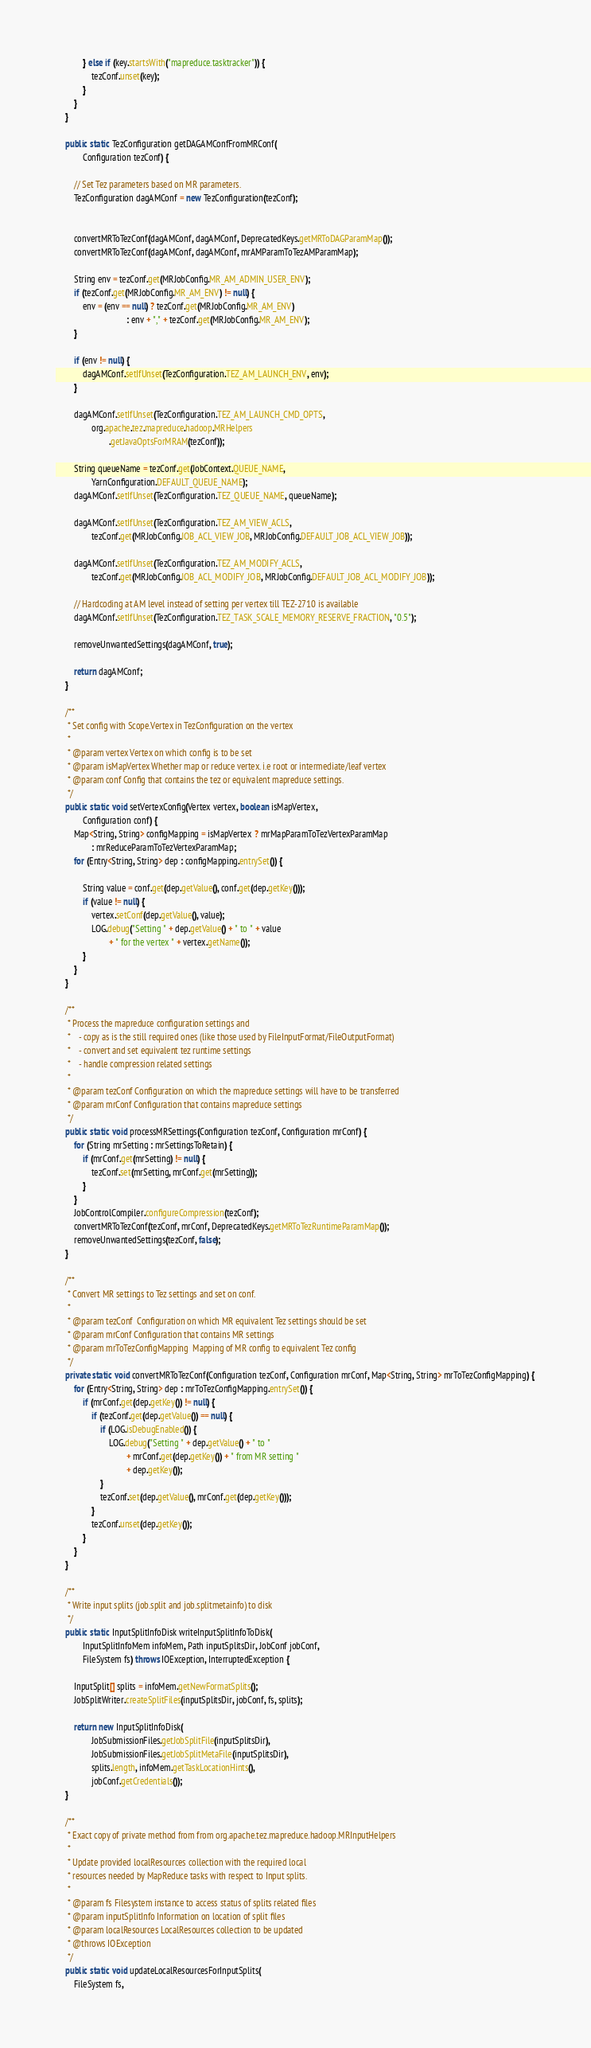<code> <loc_0><loc_0><loc_500><loc_500><_Java_>            } else if (key.startsWith("mapreduce.tasktracker")) {
                tezConf.unset(key);
            }
        }
    }

    public static TezConfiguration getDAGAMConfFromMRConf(
            Configuration tezConf) {

        // Set Tez parameters based on MR parameters.
        TezConfiguration dagAMConf = new TezConfiguration(tezConf);


        convertMRToTezConf(dagAMConf, dagAMConf, DeprecatedKeys.getMRToDAGParamMap());
        convertMRToTezConf(dagAMConf, dagAMConf, mrAMParamToTezAMParamMap);

        String env = tezConf.get(MRJobConfig.MR_AM_ADMIN_USER_ENV);
        if (tezConf.get(MRJobConfig.MR_AM_ENV) != null) {
            env = (env == null) ? tezConf.get(MRJobConfig.MR_AM_ENV)
                                : env + "," + tezConf.get(MRJobConfig.MR_AM_ENV);
        }

        if (env != null) {
            dagAMConf.setIfUnset(TezConfiguration.TEZ_AM_LAUNCH_ENV, env);
        }

        dagAMConf.setIfUnset(TezConfiguration.TEZ_AM_LAUNCH_CMD_OPTS,
                org.apache.tez.mapreduce.hadoop.MRHelpers
                        .getJavaOptsForMRAM(tezConf));

        String queueName = tezConf.get(JobContext.QUEUE_NAME,
                YarnConfiguration.DEFAULT_QUEUE_NAME);
        dagAMConf.setIfUnset(TezConfiguration.TEZ_QUEUE_NAME, queueName);

        dagAMConf.setIfUnset(TezConfiguration.TEZ_AM_VIEW_ACLS,
                tezConf.get(MRJobConfig.JOB_ACL_VIEW_JOB, MRJobConfig.DEFAULT_JOB_ACL_VIEW_JOB));

        dagAMConf.setIfUnset(TezConfiguration.TEZ_AM_MODIFY_ACLS,
                tezConf.get(MRJobConfig.JOB_ACL_MODIFY_JOB, MRJobConfig.DEFAULT_JOB_ACL_MODIFY_JOB));

        // Hardcoding at AM level instead of setting per vertex till TEZ-2710 is available
        dagAMConf.setIfUnset(TezConfiguration.TEZ_TASK_SCALE_MEMORY_RESERVE_FRACTION, "0.5");

        removeUnwantedSettings(dagAMConf, true);

        return dagAMConf;
    }

    /**
     * Set config with Scope.Vertex in TezConfiguration on the vertex
     *
     * @param vertex Vertex on which config is to be set
     * @param isMapVertex Whether map or reduce vertex. i.e root or intermediate/leaf vertex
     * @param conf Config that contains the tez or equivalent mapreduce settings.
     */
    public static void setVertexConfig(Vertex vertex, boolean isMapVertex,
            Configuration conf) {
        Map<String, String> configMapping = isMapVertex ? mrMapParamToTezVertexParamMap
                : mrReduceParamToTezVertexParamMap;
        for (Entry<String, String> dep : configMapping.entrySet()) {

            String value = conf.get(dep.getValue(), conf.get(dep.getKey()));
            if (value != null) {
                vertex.setConf(dep.getValue(), value);
                LOG.debug("Setting " + dep.getValue() + " to " + value
                        + " for the vertex " + vertex.getName());
            }
        }
    }

    /**
     * Process the mapreduce configuration settings and
     *    - copy as is the still required ones (like those used by FileInputFormat/FileOutputFormat)
     *    - convert and set equivalent tez runtime settings
     *    - handle compression related settings
     *
     * @param tezConf Configuration on which the mapreduce settings will have to be transferred
     * @param mrConf Configuration that contains mapreduce settings
     */
    public static void processMRSettings(Configuration tezConf, Configuration mrConf) {
        for (String mrSetting : mrSettingsToRetain) {
            if (mrConf.get(mrSetting) != null) {
                tezConf.set(mrSetting, mrConf.get(mrSetting));
            }
        }
        JobControlCompiler.configureCompression(tezConf);
        convertMRToTezConf(tezConf, mrConf, DeprecatedKeys.getMRToTezRuntimeParamMap());
        removeUnwantedSettings(tezConf, false);
    }

    /**
     * Convert MR settings to Tez settings and set on conf.
     *
     * @param tezConf  Configuration on which MR equivalent Tez settings should be set
     * @param mrConf Configuration that contains MR settings
     * @param mrToTezConfigMapping  Mapping of MR config to equivalent Tez config
     */
    private static void convertMRToTezConf(Configuration tezConf, Configuration mrConf, Map<String, String> mrToTezConfigMapping) {
        for (Entry<String, String> dep : mrToTezConfigMapping.entrySet()) {
            if (mrConf.get(dep.getKey()) != null) {
                if (tezConf.get(dep.getValue()) == null) {
                    if (LOG.isDebugEnabled()) {
                        LOG.debug("Setting " + dep.getValue() + " to "
                                + mrConf.get(dep.getKey()) + " from MR setting "
                                + dep.getKey());
                    }
                    tezConf.set(dep.getValue(), mrConf.get(dep.getKey()));
                }
                tezConf.unset(dep.getKey());
            }
        }
    }

    /**
     * Write input splits (job.split and job.splitmetainfo) to disk
     */
    public static InputSplitInfoDisk writeInputSplitInfoToDisk(
            InputSplitInfoMem infoMem, Path inputSplitsDir, JobConf jobConf,
            FileSystem fs) throws IOException, InterruptedException {

        InputSplit[] splits = infoMem.getNewFormatSplits();
        JobSplitWriter.createSplitFiles(inputSplitsDir, jobConf, fs, splits);

        return new InputSplitInfoDisk(
                JobSubmissionFiles.getJobSplitFile(inputSplitsDir),
                JobSubmissionFiles.getJobSplitMetaFile(inputSplitsDir),
                splits.length, infoMem.getTaskLocationHints(),
                jobConf.getCredentials());
    }

    /**
     * Exact copy of private method from from org.apache.tez.mapreduce.hadoop.MRInputHelpers
     *
     * Update provided localResources collection with the required local
     * resources needed by MapReduce tasks with respect to Input splits.
     *
     * @param fs Filesystem instance to access status of splits related files
     * @param inputSplitInfo Information on location of split files
     * @param localResources LocalResources collection to be updated
     * @throws IOException
     */
    public static void updateLocalResourcesForInputSplits(
        FileSystem fs,</code> 